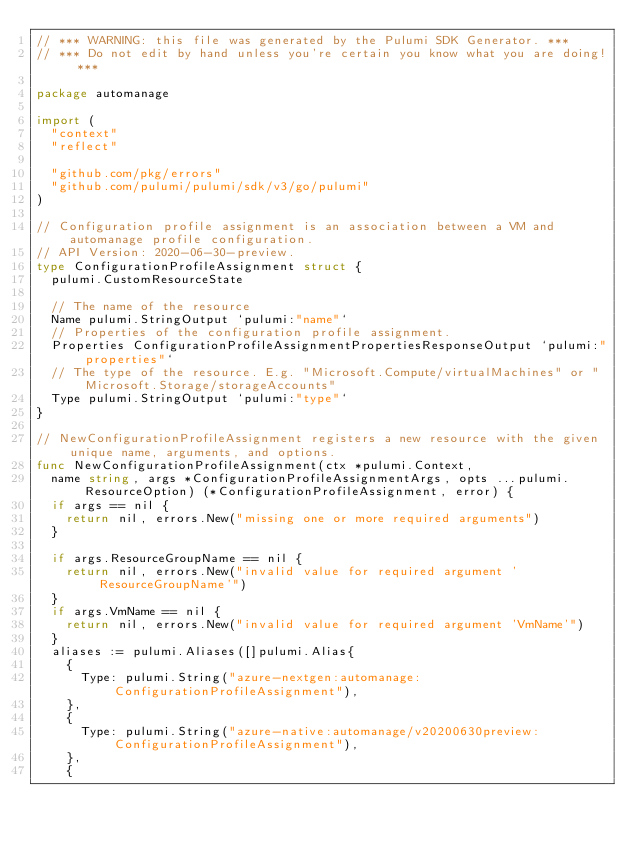Convert code to text. <code><loc_0><loc_0><loc_500><loc_500><_Go_>// *** WARNING: this file was generated by the Pulumi SDK Generator. ***
// *** Do not edit by hand unless you're certain you know what you are doing! ***

package automanage

import (
	"context"
	"reflect"

	"github.com/pkg/errors"
	"github.com/pulumi/pulumi/sdk/v3/go/pulumi"
)

// Configuration profile assignment is an association between a VM and automanage profile configuration.
// API Version: 2020-06-30-preview.
type ConfigurationProfileAssignment struct {
	pulumi.CustomResourceState

	// The name of the resource
	Name pulumi.StringOutput `pulumi:"name"`
	// Properties of the configuration profile assignment.
	Properties ConfigurationProfileAssignmentPropertiesResponseOutput `pulumi:"properties"`
	// The type of the resource. E.g. "Microsoft.Compute/virtualMachines" or "Microsoft.Storage/storageAccounts"
	Type pulumi.StringOutput `pulumi:"type"`
}

// NewConfigurationProfileAssignment registers a new resource with the given unique name, arguments, and options.
func NewConfigurationProfileAssignment(ctx *pulumi.Context,
	name string, args *ConfigurationProfileAssignmentArgs, opts ...pulumi.ResourceOption) (*ConfigurationProfileAssignment, error) {
	if args == nil {
		return nil, errors.New("missing one or more required arguments")
	}

	if args.ResourceGroupName == nil {
		return nil, errors.New("invalid value for required argument 'ResourceGroupName'")
	}
	if args.VmName == nil {
		return nil, errors.New("invalid value for required argument 'VmName'")
	}
	aliases := pulumi.Aliases([]pulumi.Alias{
		{
			Type: pulumi.String("azure-nextgen:automanage:ConfigurationProfileAssignment"),
		},
		{
			Type: pulumi.String("azure-native:automanage/v20200630preview:ConfigurationProfileAssignment"),
		},
		{</code> 